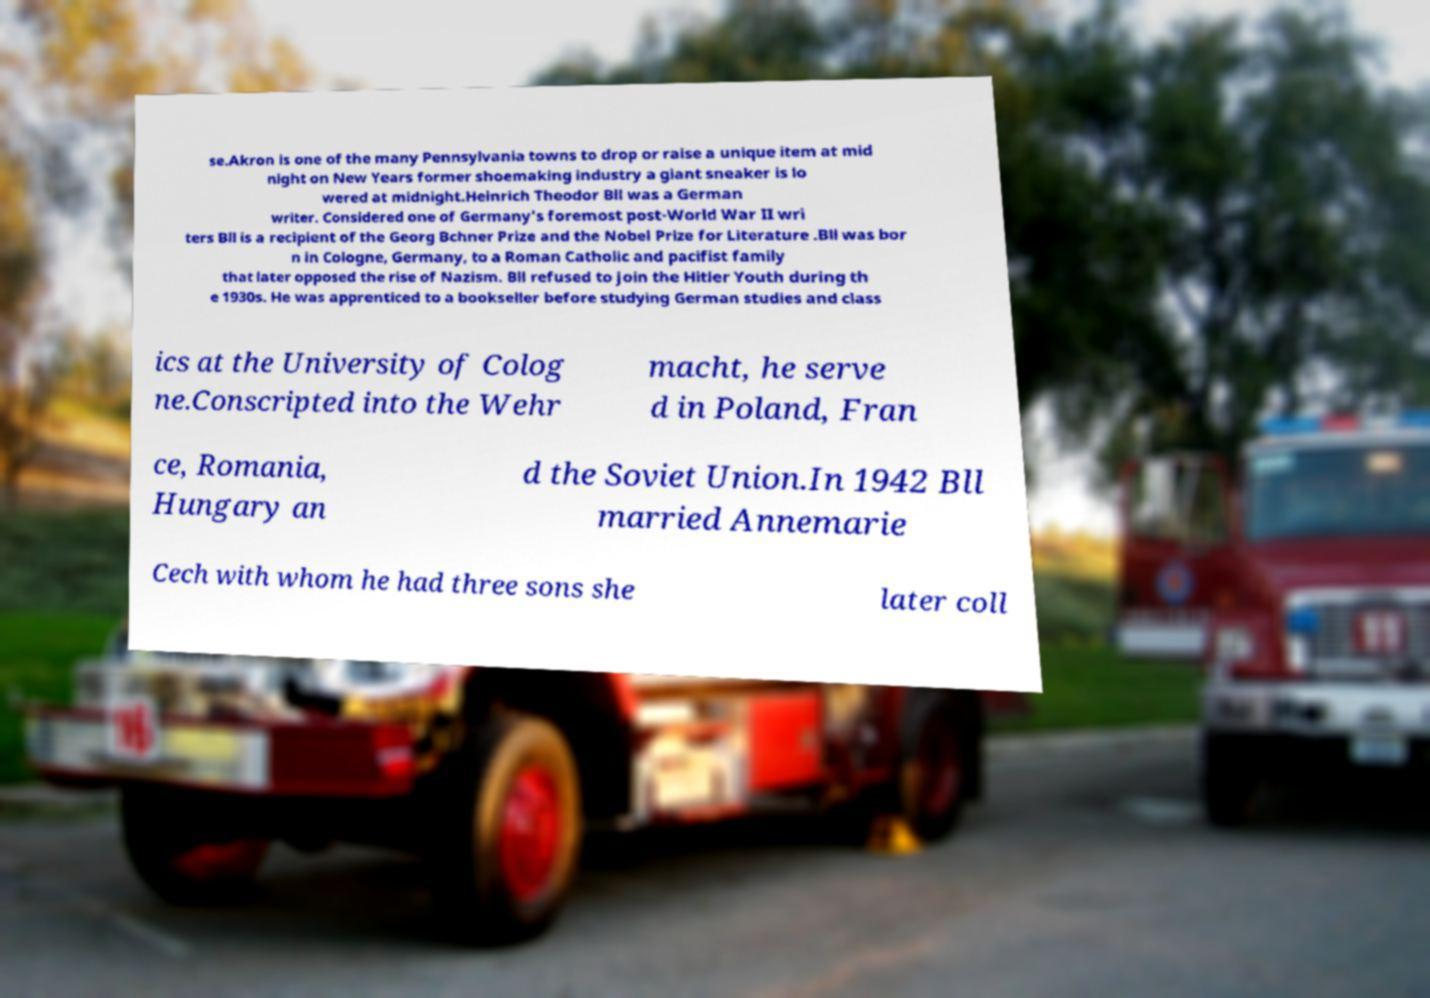For documentation purposes, I need the text within this image transcribed. Could you provide that? se.Akron is one of the many Pennsylvania towns to drop or raise a unique item at mid night on New Years former shoemaking industry a giant sneaker is lo wered at midnight.Heinrich Theodor Bll was a German writer. Considered one of Germany's foremost post-World War II wri ters Bll is a recipient of the Georg Bchner Prize and the Nobel Prize for Literature .Bll was bor n in Cologne, Germany, to a Roman Catholic and pacifist family that later opposed the rise of Nazism. Bll refused to join the Hitler Youth during th e 1930s. He was apprenticed to a bookseller before studying German studies and class ics at the University of Colog ne.Conscripted into the Wehr macht, he serve d in Poland, Fran ce, Romania, Hungary an d the Soviet Union.In 1942 Bll married Annemarie Cech with whom he had three sons she later coll 